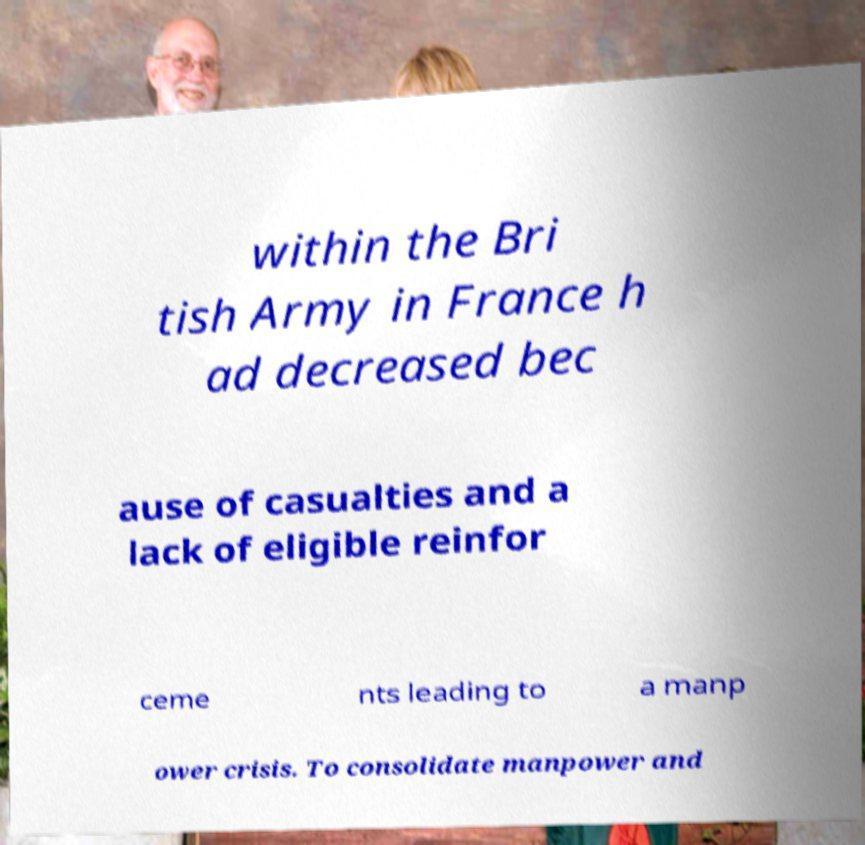Could you assist in decoding the text presented in this image and type it out clearly? within the Bri tish Army in France h ad decreased bec ause of casualties and a lack of eligible reinfor ceme nts leading to a manp ower crisis. To consolidate manpower and 